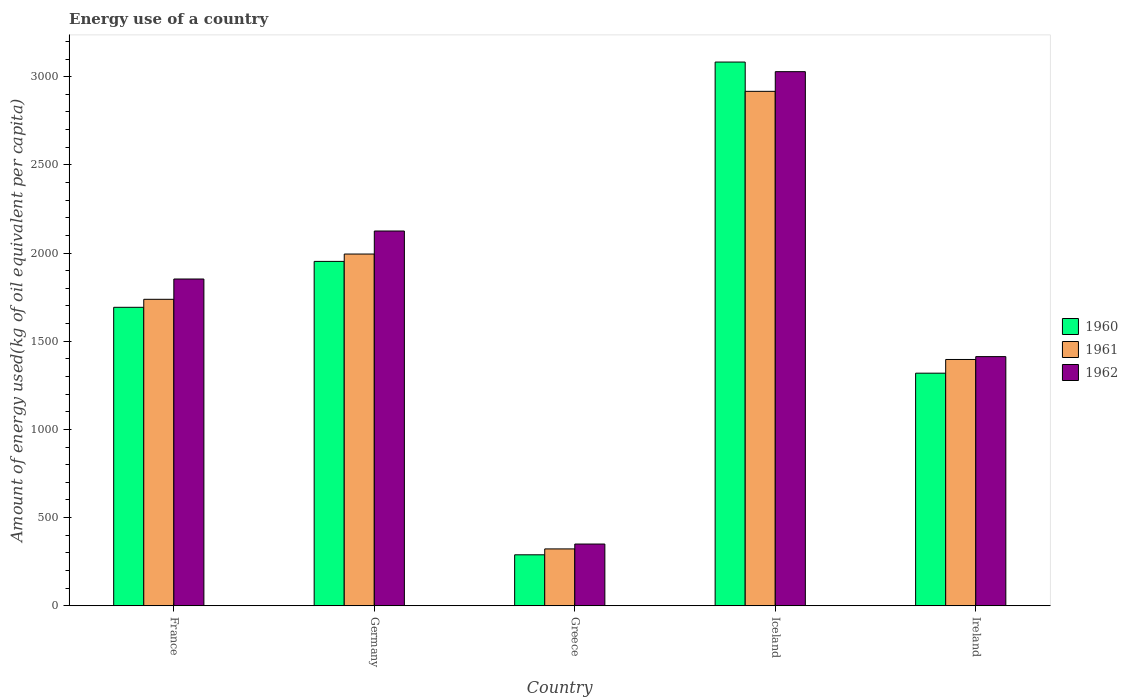How many different coloured bars are there?
Ensure brevity in your answer.  3. Are the number of bars per tick equal to the number of legend labels?
Offer a terse response. Yes. Are the number of bars on each tick of the X-axis equal?
Your answer should be very brief. Yes. How many bars are there on the 1st tick from the left?
Provide a succinct answer. 3. What is the label of the 3rd group of bars from the left?
Your response must be concise. Greece. What is the amount of energy used in in 1962 in Iceland?
Keep it short and to the point. 3028.3. Across all countries, what is the maximum amount of energy used in in 1962?
Give a very brief answer. 3028.3. Across all countries, what is the minimum amount of energy used in in 1962?
Offer a very short reply. 350.1. What is the total amount of energy used in in 1960 in the graph?
Your answer should be very brief. 8335.43. What is the difference between the amount of energy used in in 1961 in France and that in Germany?
Your answer should be very brief. -256.64. What is the difference between the amount of energy used in in 1960 in Iceland and the amount of energy used in in 1962 in France?
Ensure brevity in your answer.  1229.98. What is the average amount of energy used in in 1960 per country?
Provide a short and direct response. 1667.09. What is the difference between the amount of energy used in of/in 1961 and amount of energy used in of/in 1962 in Ireland?
Provide a short and direct response. -16.26. In how many countries, is the amount of energy used in in 1962 greater than 2300 kg?
Offer a terse response. 1. What is the ratio of the amount of energy used in in 1961 in Germany to that in Greece?
Offer a very short reply. 6.18. Is the difference between the amount of energy used in in 1961 in France and Ireland greater than the difference between the amount of energy used in in 1962 in France and Ireland?
Keep it short and to the point. No. What is the difference between the highest and the second highest amount of energy used in in 1960?
Your answer should be compact. -1130.12. What is the difference between the highest and the lowest amount of energy used in in 1960?
Keep it short and to the point. 2793.65. In how many countries, is the amount of energy used in in 1962 greater than the average amount of energy used in in 1962 taken over all countries?
Your answer should be very brief. 3. How many bars are there?
Your answer should be very brief. 15. How many countries are there in the graph?
Your answer should be compact. 5. What is the difference between two consecutive major ticks on the Y-axis?
Your answer should be compact. 500. Are the values on the major ticks of Y-axis written in scientific E-notation?
Keep it short and to the point. No. How are the legend labels stacked?
Offer a very short reply. Vertical. What is the title of the graph?
Offer a very short reply. Energy use of a country. Does "1976" appear as one of the legend labels in the graph?
Make the answer very short. No. What is the label or title of the Y-axis?
Give a very brief answer. Amount of energy used(kg of oil equivalent per capita). What is the Amount of energy used(kg of oil equivalent per capita) in 1960 in France?
Offer a terse response. 1692.26. What is the Amount of energy used(kg of oil equivalent per capita) in 1961 in France?
Provide a short and direct response. 1737.69. What is the Amount of energy used(kg of oil equivalent per capita) in 1962 in France?
Provide a short and direct response. 1852.74. What is the Amount of energy used(kg of oil equivalent per capita) of 1960 in Germany?
Ensure brevity in your answer.  1952.59. What is the Amount of energy used(kg of oil equivalent per capita) of 1961 in Germany?
Give a very brief answer. 1994.32. What is the Amount of energy used(kg of oil equivalent per capita) of 1962 in Germany?
Ensure brevity in your answer.  2124.85. What is the Amount of energy used(kg of oil equivalent per capita) of 1960 in Greece?
Offer a terse response. 289.06. What is the Amount of energy used(kg of oil equivalent per capita) in 1961 in Greece?
Offer a terse response. 322.49. What is the Amount of energy used(kg of oil equivalent per capita) in 1962 in Greece?
Ensure brevity in your answer.  350.1. What is the Amount of energy used(kg of oil equivalent per capita) in 1960 in Iceland?
Offer a very short reply. 3082.71. What is the Amount of energy used(kg of oil equivalent per capita) in 1961 in Iceland?
Your answer should be compact. 2916.71. What is the Amount of energy used(kg of oil equivalent per capita) of 1962 in Iceland?
Provide a short and direct response. 3028.3. What is the Amount of energy used(kg of oil equivalent per capita) of 1960 in Ireland?
Offer a very short reply. 1318.81. What is the Amount of energy used(kg of oil equivalent per capita) in 1961 in Ireland?
Make the answer very short. 1396.47. What is the Amount of energy used(kg of oil equivalent per capita) in 1962 in Ireland?
Offer a very short reply. 1412.73. Across all countries, what is the maximum Amount of energy used(kg of oil equivalent per capita) of 1960?
Offer a very short reply. 3082.71. Across all countries, what is the maximum Amount of energy used(kg of oil equivalent per capita) in 1961?
Provide a short and direct response. 2916.71. Across all countries, what is the maximum Amount of energy used(kg of oil equivalent per capita) of 1962?
Your response must be concise. 3028.3. Across all countries, what is the minimum Amount of energy used(kg of oil equivalent per capita) in 1960?
Offer a very short reply. 289.06. Across all countries, what is the minimum Amount of energy used(kg of oil equivalent per capita) in 1961?
Make the answer very short. 322.49. Across all countries, what is the minimum Amount of energy used(kg of oil equivalent per capita) of 1962?
Keep it short and to the point. 350.1. What is the total Amount of energy used(kg of oil equivalent per capita) in 1960 in the graph?
Ensure brevity in your answer.  8335.43. What is the total Amount of energy used(kg of oil equivalent per capita) of 1961 in the graph?
Your response must be concise. 8367.68. What is the total Amount of energy used(kg of oil equivalent per capita) of 1962 in the graph?
Keep it short and to the point. 8768.71. What is the difference between the Amount of energy used(kg of oil equivalent per capita) in 1960 in France and that in Germany?
Ensure brevity in your answer.  -260.33. What is the difference between the Amount of energy used(kg of oil equivalent per capita) of 1961 in France and that in Germany?
Offer a terse response. -256.64. What is the difference between the Amount of energy used(kg of oil equivalent per capita) in 1962 in France and that in Germany?
Keep it short and to the point. -272.11. What is the difference between the Amount of energy used(kg of oil equivalent per capita) of 1960 in France and that in Greece?
Give a very brief answer. 1403.2. What is the difference between the Amount of energy used(kg of oil equivalent per capita) in 1961 in France and that in Greece?
Ensure brevity in your answer.  1415.2. What is the difference between the Amount of energy used(kg of oil equivalent per capita) in 1962 in France and that in Greece?
Your answer should be very brief. 1502.63. What is the difference between the Amount of energy used(kg of oil equivalent per capita) in 1960 in France and that in Iceland?
Keep it short and to the point. -1390.45. What is the difference between the Amount of energy used(kg of oil equivalent per capita) in 1961 in France and that in Iceland?
Offer a terse response. -1179.02. What is the difference between the Amount of energy used(kg of oil equivalent per capita) of 1962 in France and that in Iceland?
Offer a very short reply. -1175.56. What is the difference between the Amount of energy used(kg of oil equivalent per capita) in 1960 in France and that in Ireland?
Provide a succinct answer. 373.45. What is the difference between the Amount of energy used(kg of oil equivalent per capita) of 1961 in France and that in Ireland?
Give a very brief answer. 341.22. What is the difference between the Amount of energy used(kg of oil equivalent per capita) in 1962 in France and that in Ireland?
Make the answer very short. 440.01. What is the difference between the Amount of energy used(kg of oil equivalent per capita) in 1960 in Germany and that in Greece?
Offer a terse response. 1663.53. What is the difference between the Amount of energy used(kg of oil equivalent per capita) of 1961 in Germany and that in Greece?
Give a very brief answer. 1671.83. What is the difference between the Amount of energy used(kg of oil equivalent per capita) of 1962 in Germany and that in Greece?
Your response must be concise. 1774.75. What is the difference between the Amount of energy used(kg of oil equivalent per capita) of 1960 in Germany and that in Iceland?
Provide a short and direct response. -1130.12. What is the difference between the Amount of energy used(kg of oil equivalent per capita) of 1961 in Germany and that in Iceland?
Provide a short and direct response. -922.38. What is the difference between the Amount of energy used(kg of oil equivalent per capita) of 1962 in Germany and that in Iceland?
Your answer should be very brief. -903.45. What is the difference between the Amount of energy used(kg of oil equivalent per capita) of 1960 in Germany and that in Ireland?
Make the answer very short. 633.78. What is the difference between the Amount of energy used(kg of oil equivalent per capita) of 1961 in Germany and that in Ireland?
Make the answer very short. 597.86. What is the difference between the Amount of energy used(kg of oil equivalent per capita) in 1962 in Germany and that in Ireland?
Provide a short and direct response. 712.12. What is the difference between the Amount of energy used(kg of oil equivalent per capita) in 1960 in Greece and that in Iceland?
Give a very brief answer. -2793.65. What is the difference between the Amount of energy used(kg of oil equivalent per capita) of 1961 in Greece and that in Iceland?
Offer a terse response. -2594.22. What is the difference between the Amount of energy used(kg of oil equivalent per capita) in 1962 in Greece and that in Iceland?
Your response must be concise. -2678.2. What is the difference between the Amount of energy used(kg of oil equivalent per capita) in 1960 in Greece and that in Ireland?
Keep it short and to the point. -1029.76. What is the difference between the Amount of energy used(kg of oil equivalent per capita) of 1961 in Greece and that in Ireland?
Your response must be concise. -1073.98. What is the difference between the Amount of energy used(kg of oil equivalent per capita) of 1962 in Greece and that in Ireland?
Give a very brief answer. -1062.63. What is the difference between the Amount of energy used(kg of oil equivalent per capita) of 1960 in Iceland and that in Ireland?
Provide a short and direct response. 1763.9. What is the difference between the Amount of energy used(kg of oil equivalent per capita) in 1961 in Iceland and that in Ireland?
Your response must be concise. 1520.24. What is the difference between the Amount of energy used(kg of oil equivalent per capita) of 1962 in Iceland and that in Ireland?
Make the answer very short. 1615.57. What is the difference between the Amount of energy used(kg of oil equivalent per capita) of 1960 in France and the Amount of energy used(kg of oil equivalent per capita) of 1961 in Germany?
Offer a very short reply. -302.06. What is the difference between the Amount of energy used(kg of oil equivalent per capita) of 1960 in France and the Amount of energy used(kg of oil equivalent per capita) of 1962 in Germany?
Make the answer very short. -432.59. What is the difference between the Amount of energy used(kg of oil equivalent per capita) in 1961 in France and the Amount of energy used(kg of oil equivalent per capita) in 1962 in Germany?
Your answer should be very brief. -387.16. What is the difference between the Amount of energy used(kg of oil equivalent per capita) in 1960 in France and the Amount of energy used(kg of oil equivalent per capita) in 1961 in Greece?
Provide a short and direct response. 1369.77. What is the difference between the Amount of energy used(kg of oil equivalent per capita) in 1960 in France and the Amount of energy used(kg of oil equivalent per capita) in 1962 in Greece?
Give a very brief answer. 1342.16. What is the difference between the Amount of energy used(kg of oil equivalent per capita) in 1961 in France and the Amount of energy used(kg of oil equivalent per capita) in 1962 in Greece?
Your answer should be compact. 1387.59. What is the difference between the Amount of energy used(kg of oil equivalent per capita) of 1960 in France and the Amount of energy used(kg of oil equivalent per capita) of 1961 in Iceland?
Provide a short and direct response. -1224.44. What is the difference between the Amount of energy used(kg of oil equivalent per capita) in 1960 in France and the Amount of energy used(kg of oil equivalent per capita) in 1962 in Iceland?
Provide a short and direct response. -1336.04. What is the difference between the Amount of energy used(kg of oil equivalent per capita) in 1961 in France and the Amount of energy used(kg of oil equivalent per capita) in 1962 in Iceland?
Give a very brief answer. -1290.61. What is the difference between the Amount of energy used(kg of oil equivalent per capita) in 1960 in France and the Amount of energy used(kg of oil equivalent per capita) in 1961 in Ireland?
Keep it short and to the point. 295.8. What is the difference between the Amount of energy used(kg of oil equivalent per capita) in 1960 in France and the Amount of energy used(kg of oil equivalent per capita) in 1962 in Ireland?
Make the answer very short. 279.53. What is the difference between the Amount of energy used(kg of oil equivalent per capita) in 1961 in France and the Amount of energy used(kg of oil equivalent per capita) in 1962 in Ireland?
Your answer should be compact. 324.96. What is the difference between the Amount of energy used(kg of oil equivalent per capita) of 1960 in Germany and the Amount of energy used(kg of oil equivalent per capita) of 1961 in Greece?
Provide a succinct answer. 1630.1. What is the difference between the Amount of energy used(kg of oil equivalent per capita) in 1960 in Germany and the Amount of energy used(kg of oil equivalent per capita) in 1962 in Greece?
Provide a short and direct response. 1602.49. What is the difference between the Amount of energy used(kg of oil equivalent per capita) in 1961 in Germany and the Amount of energy used(kg of oil equivalent per capita) in 1962 in Greece?
Your response must be concise. 1644.22. What is the difference between the Amount of energy used(kg of oil equivalent per capita) of 1960 in Germany and the Amount of energy used(kg of oil equivalent per capita) of 1961 in Iceland?
Ensure brevity in your answer.  -964.12. What is the difference between the Amount of energy used(kg of oil equivalent per capita) of 1960 in Germany and the Amount of energy used(kg of oil equivalent per capita) of 1962 in Iceland?
Your response must be concise. -1075.71. What is the difference between the Amount of energy used(kg of oil equivalent per capita) in 1961 in Germany and the Amount of energy used(kg of oil equivalent per capita) in 1962 in Iceland?
Offer a terse response. -1033.97. What is the difference between the Amount of energy used(kg of oil equivalent per capita) in 1960 in Germany and the Amount of energy used(kg of oil equivalent per capita) in 1961 in Ireland?
Provide a succinct answer. 556.12. What is the difference between the Amount of energy used(kg of oil equivalent per capita) of 1960 in Germany and the Amount of energy used(kg of oil equivalent per capita) of 1962 in Ireland?
Your answer should be compact. 539.86. What is the difference between the Amount of energy used(kg of oil equivalent per capita) in 1961 in Germany and the Amount of energy used(kg of oil equivalent per capita) in 1962 in Ireland?
Your response must be concise. 581.6. What is the difference between the Amount of energy used(kg of oil equivalent per capita) in 1960 in Greece and the Amount of energy used(kg of oil equivalent per capita) in 1961 in Iceland?
Your answer should be compact. -2627.65. What is the difference between the Amount of energy used(kg of oil equivalent per capita) of 1960 in Greece and the Amount of energy used(kg of oil equivalent per capita) of 1962 in Iceland?
Your answer should be very brief. -2739.24. What is the difference between the Amount of energy used(kg of oil equivalent per capita) in 1961 in Greece and the Amount of energy used(kg of oil equivalent per capita) in 1962 in Iceland?
Keep it short and to the point. -2705.81. What is the difference between the Amount of energy used(kg of oil equivalent per capita) of 1960 in Greece and the Amount of energy used(kg of oil equivalent per capita) of 1961 in Ireland?
Ensure brevity in your answer.  -1107.41. What is the difference between the Amount of energy used(kg of oil equivalent per capita) in 1960 in Greece and the Amount of energy used(kg of oil equivalent per capita) in 1962 in Ireland?
Your response must be concise. -1123.67. What is the difference between the Amount of energy used(kg of oil equivalent per capita) in 1961 in Greece and the Amount of energy used(kg of oil equivalent per capita) in 1962 in Ireland?
Provide a short and direct response. -1090.24. What is the difference between the Amount of energy used(kg of oil equivalent per capita) in 1960 in Iceland and the Amount of energy used(kg of oil equivalent per capita) in 1961 in Ireland?
Offer a terse response. 1686.25. What is the difference between the Amount of energy used(kg of oil equivalent per capita) in 1960 in Iceland and the Amount of energy used(kg of oil equivalent per capita) in 1962 in Ireland?
Make the answer very short. 1669.98. What is the difference between the Amount of energy used(kg of oil equivalent per capita) in 1961 in Iceland and the Amount of energy used(kg of oil equivalent per capita) in 1962 in Ireland?
Keep it short and to the point. 1503.98. What is the average Amount of energy used(kg of oil equivalent per capita) of 1960 per country?
Make the answer very short. 1667.09. What is the average Amount of energy used(kg of oil equivalent per capita) of 1961 per country?
Give a very brief answer. 1673.54. What is the average Amount of energy used(kg of oil equivalent per capita) of 1962 per country?
Offer a terse response. 1753.74. What is the difference between the Amount of energy used(kg of oil equivalent per capita) in 1960 and Amount of energy used(kg of oil equivalent per capita) in 1961 in France?
Provide a short and direct response. -45.43. What is the difference between the Amount of energy used(kg of oil equivalent per capita) in 1960 and Amount of energy used(kg of oil equivalent per capita) in 1962 in France?
Offer a terse response. -160.47. What is the difference between the Amount of energy used(kg of oil equivalent per capita) in 1961 and Amount of energy used(kg of oil equivalent per capita) in 1962 in France?
Provide a succinct answer. -115.05. What is the difference between the Amount of energy used(kg of oil equivalent per capita) of 1960 and Amount of energy used(kg of oil equivalent per capita) of 1961 in Germany?
Ensure brevity in your answer.  -41.74. What is the difference between the Amount of energy used(kg of oil equivalent per capita) of 1960 and Amount of energy used(kg of oil equivalent per capita) of 1962 in Germany?
Your answer should be very brief. -172.26. What is the difference between the Amount of energy used(kg of oil equivalent per capita) of 1961 and Amount of energy used(kg of oil equivalent per capita) of 1962 in Germany?
Offer a terse response. -130.52. What is the difference between the Amount of energy used(kg of oil equivalent per capita) in 1960 and Amount of energy used(kg of oil equivalent per capita) in 1961 in Greece?
Your answer should be compact. -33.43. What is the difference between the Amount of energy used(kg of oil equivalent per capita) of 1960 and Amount of energy used(kg of oil equivalent per capita) of 1962 in Greece?
Your answer should be very brief. -61.04. What is the difference between the Amount of energy used(kg of oil equivalent per capita) of 1961 and Amount of energy used(kg of oil equivalent per capita) of 1962 in Greece?
Ensure brevity in your answer.  -27.61. What is the difference between the Amount of energy used(kg of oil equivalent per capita) in 1960 and Amount of energy used(kg of oil equivalent per capita) in 1961 in Iceland?
Keep it short and to the point. 166.01. What is the difference between the Amount of energy used(kg of oil equivalent per capita) in 1960 and Amount of energy used(kg of oil equivalent per capita) in 1962 in Iceland?
Give a very brief answer. 54.41. What is the difference between the Amount of energy used(kg of oil equivalent per capita) of 1961 and Amount of energy used(kg of oil equivalent per capita) of 1962 in Iceland?
Make the answer very short. -111.59. What is the difference between the Amount of energy used(kg of oil equivalent per capita) of 1960 and Amount of energy used(kg of oil equivalent per capita) of 1961 in Ireland?
Give a very brief answer. -77.65. What is the difference between the Amount of energy used(kg of oil equivalent per capita) in 1960 and Amount of energy used(kg of oil equivalent per capita) in 1962 in Ireland?
Give a very brief answer. -93.92. What is the difference between the Amount of energy used(kg of oil equivalent per capita) in 1961 and Amount of energy used(kg of oil equivalent per capita) in 1962 in Ireland?
Offer a terse response. -16.26. What is the ratio of the Amount of energy used(kg of oil equivalent per capita) in 1960 in France to that in Germany?
Make the answer very short. 0.87. What is the ratio of the Amount of energy used(kg of oil equivalent per capita) of 1961 in France to that in Germany?
Ensure brevity in your answer.  0.87. What is the ratio of the Amount of energy used(kg of oil equivalent per capita) in 1962 in France to that in Germany?
Ensure brevity in your answer.  0.87. What is the ratio of the Amount of energy used(kg of oil equivalent per capita) in 1960 in France to that in Greece?
Keep it short and to the point. 5.85. What is the ratio of the Amount of energy used(kg of oil equivalent per capita) of 1961 in France to that in Greece?
Offer a terse response. 5.39. What is the ratio of the Amount of energy used(kg of oil equivalent per capita) of 1962 in France to that in Greece?
Provide a short and direct response. 5.29. What is the ratio of the Amount of energy used(kg of oil equivalent per capita) of 1960 in France to that in Iceland?
Your answer should be compact. 0.55. What is the ratio of the Amount of energy used(kg of oil equivalent per capita) in 1961 in France to that in Iceland?
Offer a very short reply. 0.6. What is the ratio of the Amount of energy used(kg of oil equivalent per capita) in 1962 in France to that in Iceland?
Provide a succinct answer. 0.61. What is the ratio of the Amount of energy used(kg of oil equivalent per capita) of 1960 in France to that in Ireland?
Your response must be concise. 1.28. What is the ratio of the Amount of energy used(kg of oil equivalent per capita) of 1961 in France to that in Ireland?
Give a very brief answer. 1.24. What is the ratio of the Amount of energy used(kg of oil equivalent per capita) of 1962 in France to that in Ireland?
Provide a succinct answer. 1.31. What is the ratio of the Amount of energy used(kg of oil equivalent per capita) in 1960 in Germany to that in Greece?
Your answer should be compact. 6.75. What is the ratio of the Amount of energy used(kg of oil equivalent per capita) in 1961 in Germany to that in Greece?
Provide a short and direct response. 6.18. What is the ratio of the Amount of energy used(kg of oil equivalent per capita) in 1962 in Germany to that in Greece?
Provide a short and direct response. 6.07. What is the ratio of the Amount of energy used(kg of oil equivalent per capita) of 1960 in Germany to that in Iceland?
Give a very brief answer. 0.63. What is the ratio of the Amount of energy used(kg of oil equivalent per capita) in 1961 in Germany to that in Iceland?
Your answer should be very brief. 0.68. What is the ratio of the Amount of energy used(kg of oil equivalent per capita) of 1962 in Germany to that in Iceland?
Your response must be concise. 0.7. What is the ratio of the Amount of energy used(kg of oil equivalent per capita) of 1960 in Germany to that in Ireland?
Keep it short and to the point. 1.48. What is the ratio of the Amount of energy used(kg of oil equivalent per capita) of 1961 in Germany to that in Ireland?
Ensure brevity in your answer.  1.43. What is the ratio of the Amount of energy used(kg of oil equivalent per capita) in 1962 in Germany to that in Ireland?
Your response must be concise. 1.5. What is the ratio of the Amount of energy used(kg of oil equivalent per capita) of 1960 in Greece to that in Iceland?
Provide a succinct answer. 0.09. What is the ratio of the Amount of energy used(kg of oil equivalent per capita) in 1961 in Greece to that in Iceland?
Give a very brief answer. 0.11. What is the ratio of the Amount of energy used(kg of oil equivalent per capita) in 1962 in Greece to that in Iceland?
Your answer should be compact. 0.12. What is the ratio of the Amount of energy used(kg of oil equivalent per capita) of 1960 in Greece to that in Ireland?
Provide a succinct answer. 0.22. What is the ratio of the Amount of energy used(kg of oil equivalent per capita) in 1961 in Greece to that in Ireland?
Keep it short and to the point. 0.23. What is the ratio of the Amount of energy used(kg of oil equivalent per capita) of 1962 in Greece to that in Ireland?
Your response must be concise. 0.25. What is the ratio of the Amount of energy used(kg of oil equivalent per capita) of 1960 in Iceland to that in Ireland?
Provide a short and direct response. 2.34. What is the ratio of the Amount of energy used(kg of oil equivalent per capita) of 1961 in Iceland to that in Ireland?
Provide a succinct answer. 2.09. What is the ratio of the Amount of energy used(kg of oil equivalent per capita) of 1962 in Iceland to that in Ireland?
Provide a succinct answer. 2.14. What is the difference between the highest and the second highest Amount of energy used(kg of oil equivalent per capita) in 1960?
Give a very brief answer. 1130.12. What is the difference between the highest and the second highest Amount of energy used(kg of oil equivalent per capita) in 1961?
Offer a terse response. 922.38. What is the difference between the highest and the second highest Amount of energy used(kg of oil equivalent per capita) of 1962?
Give a very brief answer. 903.45. What is the difference between the highest and the lowest Amount of energy used(kg of oil equivalent per capita) of 1960?
Your answer should be compact. 2793.65. What is the difference between the highest and the lowest Amount of energy used(kg of oil equivalent per capita) of 1961?
Offer a very short reply. 2594.22. What is the difference between the highest and the lowest Amount of energy used(kg of oil equivalent per capita) of 1962?
Your answer should be very brief. 2678.2. 